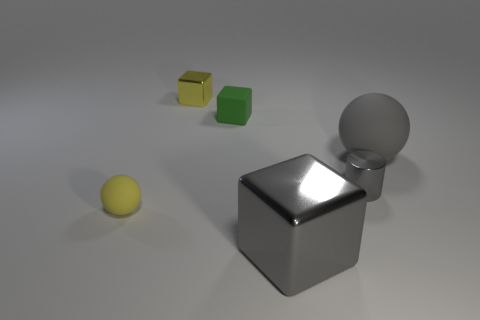How big is the yellow sphere?
Your answer should be very brief. Small. There is a tiny green object; is its shape the same as the shiny thing that is behind the gray matte object?
Keep it short and to the point. Yes. There is another ball that is the same material as the big gray sphere; what color is it?
Make the answer very short. Yellow. How big is the rubber sphere that is right of the tiny sphere?
Your answer should be very brief. Large. Are there fewer yellow rubber spheres in front of the small green object than rubber things?
Give a very brief answer. Yes. Does the small metallic cylinder have the same color as the tiny matte cube?
Offer a very short reply. No. Is there any other thing that is the same shape as the small gray object?
Keep it short and to the point. No. Are there fewer shiny cubes than gray balls?
Your response must be concise. No. What color is the tiny metal thing that is right of the small shiny thing that is behind the small green object?
Make the answer very short. Gray. There is a big thing behind the rubber sphere left of the rubber ball that is behind the shiny cylinder; what is its material?
Make the answer very short. Rubber. 